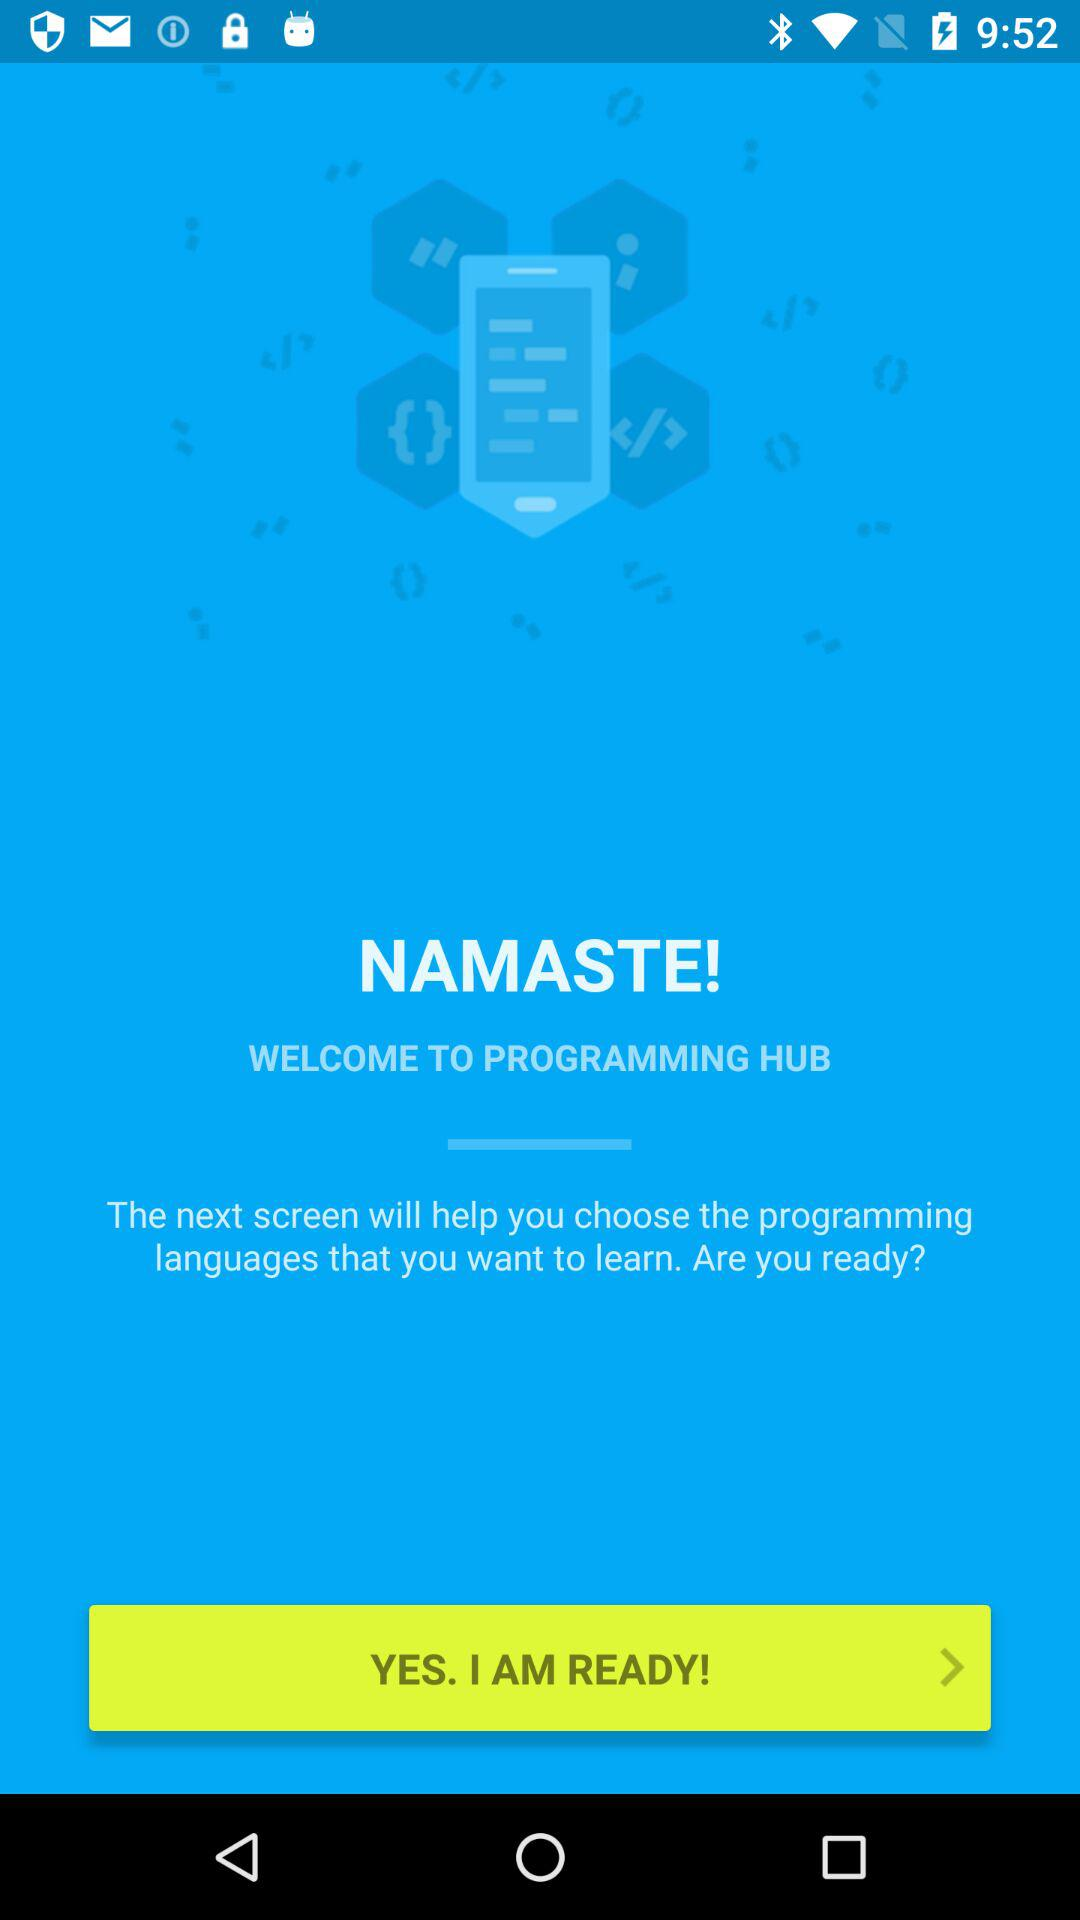What is the name of the application? The name of the application is "PROGRAMMING HUB". 